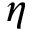<formula> <loc_0><loc_0><loc_500><loc_500>\eta</formula> 